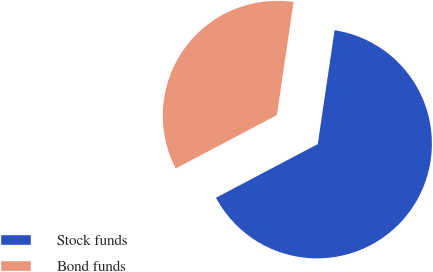Convert chart to OTSL. <chart><loc_0><loc_0><loc_500><loc_500><pie_chart><fcel>Stock funds<fcel>Bond funds<nl><fcel>64.95%<fcel>35.05%<nl></chart> 